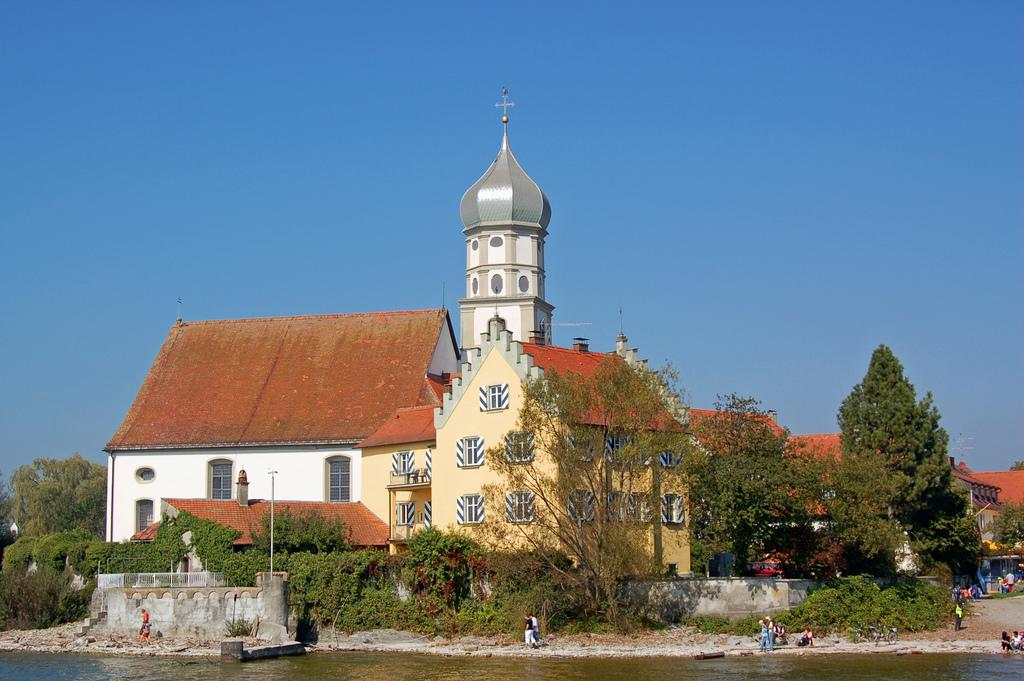What is at the bottom of the image? There is water at the bottom of the image. What can be seen near the water? There are people near the water. What is visible in the background of the image? There are trees, buildings, windows, poles, and a bicycle visible in the background. What part of the natural environment is visible in the image? The sky is visible in the background of the image. What type of air can be seen in the image? There is no air visible in the image; it is a two-dimensional representation. What kind of experience is the duck having in the image? There is no duck present in the image, so it is not possible to determine what kind of experience the duck might be having. 